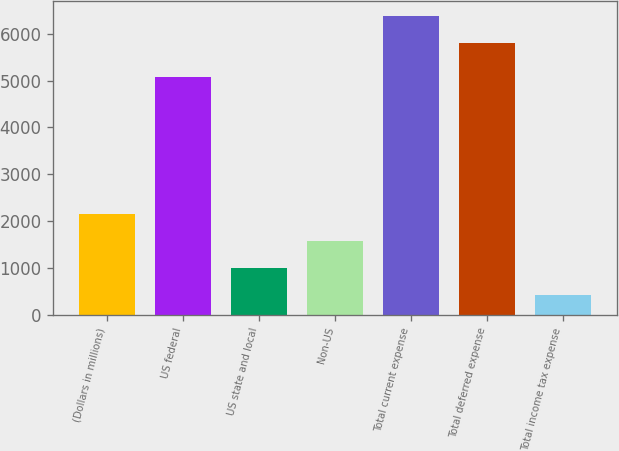<chart> <loc_0><loc_0><loc_500><loc_500><bar_chart><fcel>(Dollars in millions)<fcel>US federal<fcel>US state and local<fcel>Non-US<fcel>Total current expense<fcel>Total deferred expense<fcel>Total income tax expense<nl><fcel>2160.3<fcel>5075<fcel>1000.1<fcel>1580.2<fcel>6381.1<fcel>5801<fcel>420<nl></chart> 